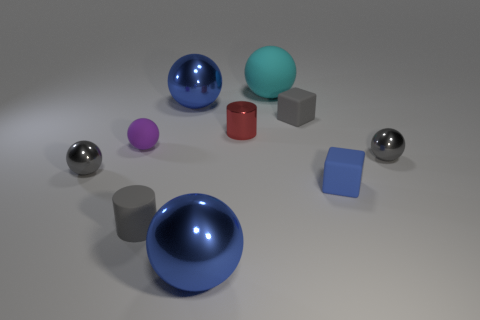Is the number of large matte spheres left of the small purple sphere less than the number of gray matte things that are on the left side of the big rubber thing?
Make the answer very short. Yes. What number of other objects are there of the same material as the purple sphere?
Provide a succinct answer. 4. What is the material of the gray block that is the same size as the rubber cylinder?
Ensure brevity in your answer.  Rubber. What number of blue objects are either small metal balls or small rubber cubes?
Keep it short and to the point. 1. What is the color of the tiny metallic thing that is in front of the tiny red cylinder and to the left of the cyan matte ball?
Provide a succinct answer. Gray. Are the big sphere in front of the blue matte object and the big blue ball that is behind the purple matte thing made of the same material?
Provide a short and direct response. Yes. Is the number of gray matte objects in front of the red cylinder greater than the number of gray objects in front of the small purple sphere?
Make the answer very short. No. There is a gray rubber thing that is the same size as the gray cube; what is its shape?
Provide a short and direct response. Cylinder. How many things are brown spheres or blue metal balls in front of the small gray rubber cylinder?
Ensure brevity in your answer.  1. Is the color of the big matte object the same as the tiny matte cylinder?
Keep it short and to the point. No. 